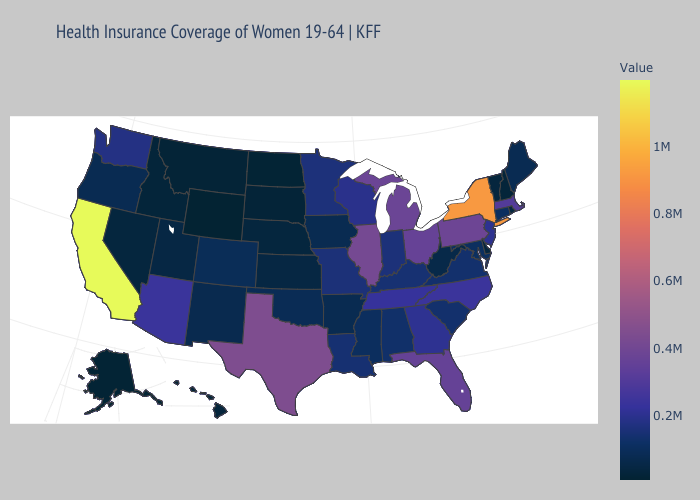Does the map have missing data?
Be succinct. No. Does Delaware have the lowest value in the South?
Be succinct. Yes. Does North Carolina have a lower value than Michigan?
Be succinct. Yes. Which states have the highest value in the USA?
Quick response, please. California. Is the legend a continuous bar?
Keep it brief. Yes. Which states have the lowest value in the USA?
Write a very short answer. Wyoming. Among the states that border Nevada , which have the highest value?
Quick response, please. California. Does Wyoming have the lowest value in the USA?
Short answer required. Yes. 